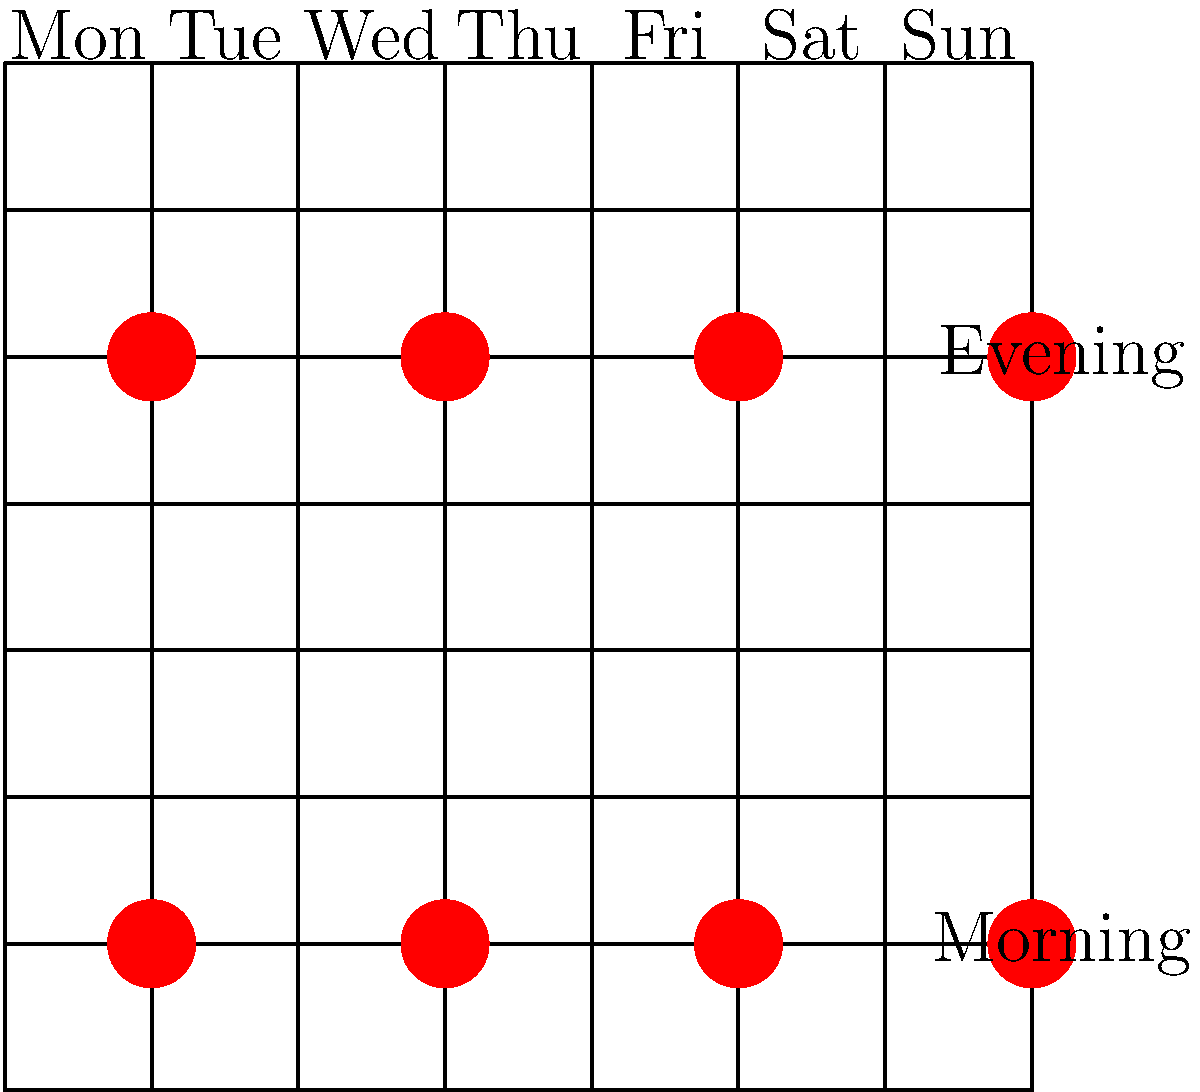Look at the feeding schedule for your new pet! The red circles show when it's time to feed. How many times do you get to feed your pet each week? Let's count the feeding times step-by-step:

1. Monday: 2 feeds (morning and evening)
2. Tuesday: No feeds
3. Wednesday: 2 feeds (morning and evening)
4. Thursday: No feeds
5. Friday: 2 feeds (morning and evening)
6. Saturday: No feeds
7. Sunday: 2 feeds (morning and evening)

Now, let's add up all the feeds:
$2 + 0 + 2 + 0 + 2 + 0 + 2 = 8$ feeds per week

So, you get to feed your pet 8 times each week!
Answer: 8 times 